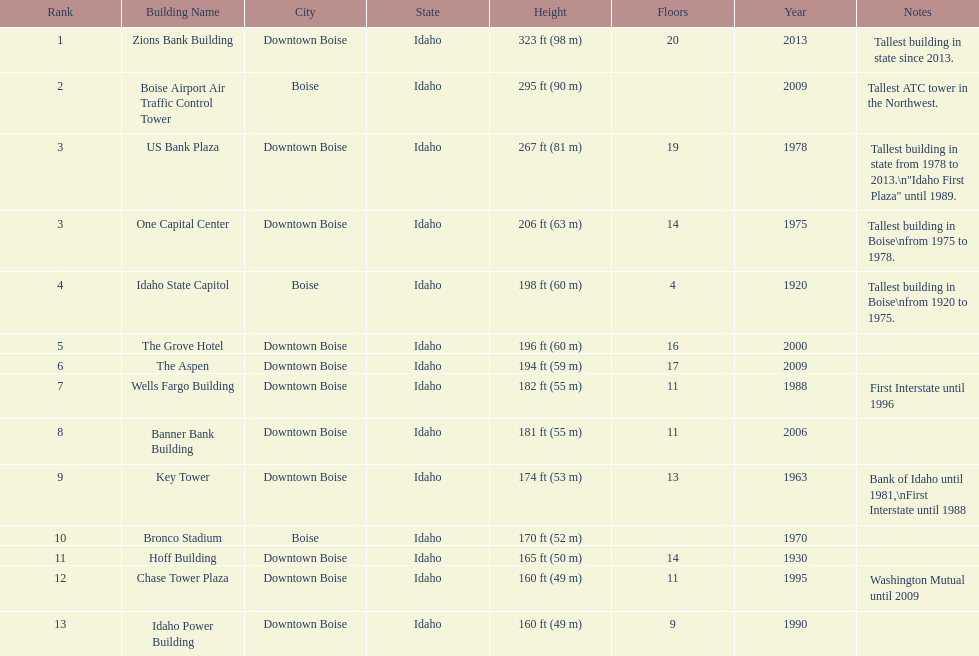What is the number of floors of the oldest building? 4. Would you be able to parse every entry in this table? {'header': ['Rank', 'Building Name', 'City', 'State', 'Height', 'Floors', 'Year', 'Notes'], 'rows': [['1', 'Zions Bank Building', 'Downtown Boise', 'Idaho', '323\xa0ft (98\xa0m)', '20', '2013', 'Tallest building in state since 2013.'], ['2', 'Boise Airport Air Traffic Control Tower', 'Boise', 'Idaho', '295\xa0ft (90\xa0m)', '', '2009', 'Tallest ATC tower in the Northwest.'], ['3', 'US Bank Plaza', 'Downtown Boise', 'Idaho', '267\xa0ft (81\xa0m)', '19', '1978', 'Tallest building in state from 1978 to 2013.\\n"Idaho First Plaza" until 1989.'], ['3', 'One Capital Center', 'Downtown Boise', 'Idaho', '206\xa0ft (63\xa0m)', '14', '1975', 'Tallest building in Boise\\nfrom 1975 to 1978.'], ['4', 'Idaho State Capitol', 'Boise', 'Idaho', '198\xa0ft (60\xa0m)', '4', '1920', 'Tallest building in Boise\\nfrom 1920 to 1975.'], ['5', 'The Grove Hotel', 'Downtown Boise', 'Idaho', '196\xa0ft (60\xa0m)', '16', '2000', ''], ['6', 'The Aspen', 'Downtown Boise', 'Idaho', '194\xa0ft (59\xa0m)', '17', '2009', ''], ['7', 'Wells Fargo Building', 'Downtown Boise', 'Idaho', '182\xa0ft (55\xa0m)', '11', '1988', 'First Interstate until 1996'], ['8', 'Banner Bank Building', 'Downtown Boise', 'Idaho', '181\xa0ft (55\xa0m)', '11', '2006', ''], ['9', 'Key Tower', 'Downtown Boise', 'Idaho', '174\xa0ft (53\xa0m)', '13', '1963', 'Bank of Idaho until 1981,\\nFirst Interstate until 1988'], ['10', 'Bronco Stadium', 'Boise', 'Idaho', '170\xa0ft (52\xa0m)', '', '1970', ''], ['11', 'Hoff Building', 'Downtown Boise', 'Idaho', '165\xa0ft (50\xa0m)', '14', '1930', ''], ['12', 'Chase Tower Plaza', 'Downtown Boise', 'Idaho', '160\xa0ft (49\xa0m)', '11', '1995', 'Washington Mutual until 2009'], ['13', 'Idaho Power Building', 'Downtown Boise', 'Idaho', '160\xa0ft (49\xa0m)', '9', '1990', '']]} 